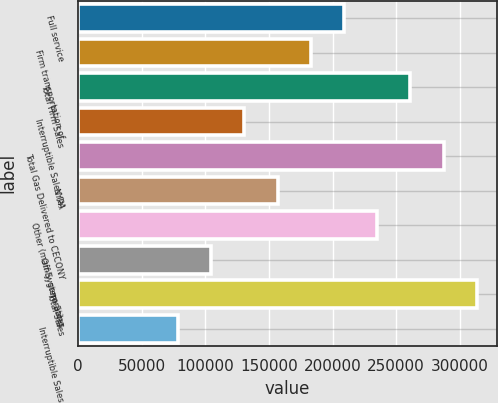Convert chart to OTSL. <chart><loc_0><loc_0><loc_500><loc_500><bar_chart><fcel>Full service<fcel>Firm transportation of<fcel>Total Firm Sales<fcel>Interruptible Sales (a)<fcel>Total Gas Delivered to CECONY<fcel>NYPA<fcel>Other (mainly generating<fcel>Off-System Sales<fcel>Total Sales<fcel>Interruptible Sales<nl><fcel>208943<fcel>182826<fcel>261175<fcel>130594<fcel>287291<fcel>156710<fcel>235059<fcel>104478<fcel>313407<fcel>78361.6<nl></chart> 